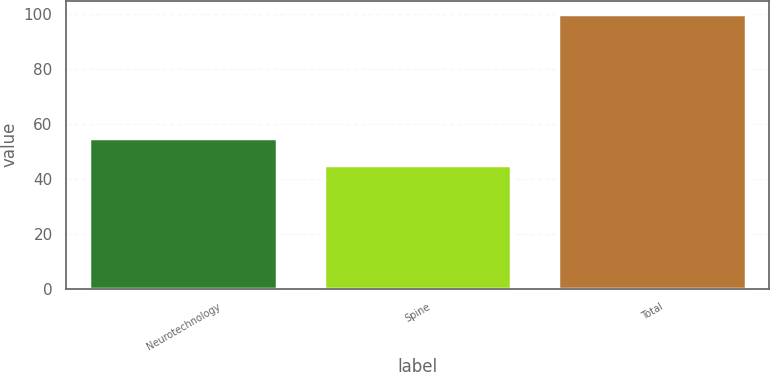Convert chart. <chart><loc_0><loc_0><loc_500><loc_500><bar_chart><fcel>Neurotechnology<fcel>Spine<fcel>Total<nl><fcel>55<fcel>45<fcel>100<nl></chart> 